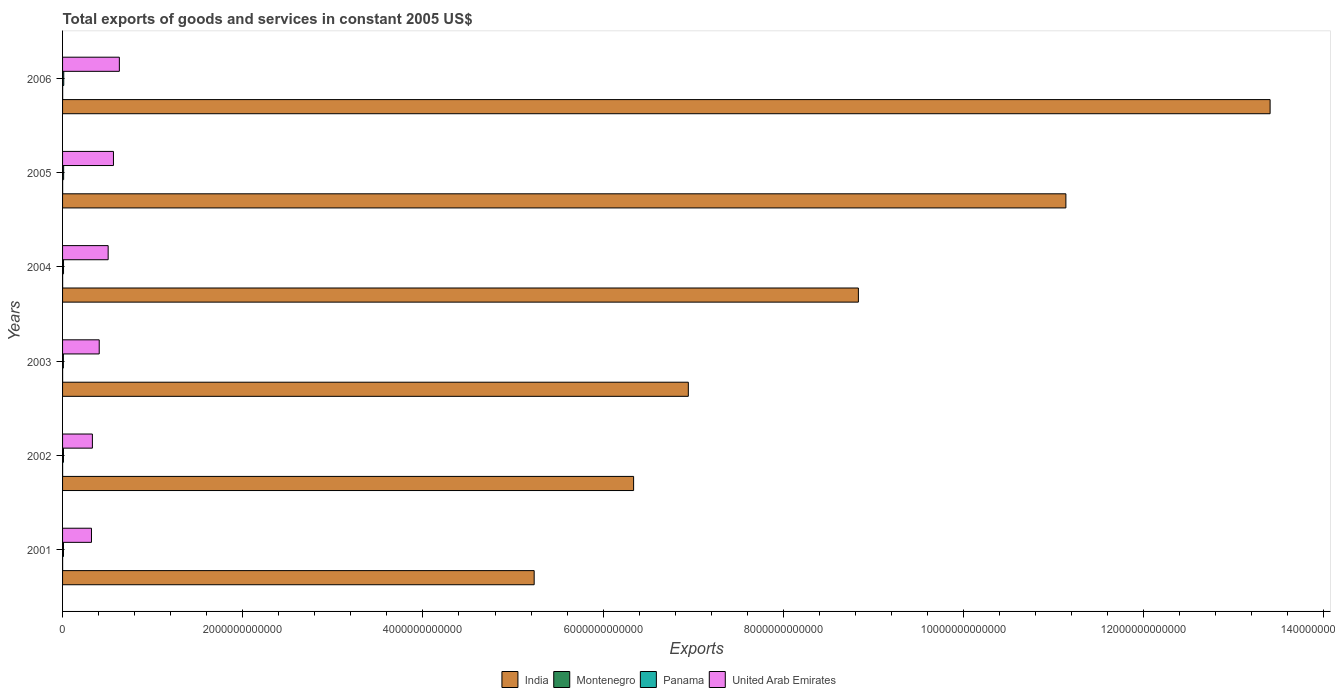How many different coloured bars are there?
Your answer should be compact. 4. How many groups of bars are there?
Your answer should be compact. 6. Are the number of bars per tick equal to the number of legend labels?
Make the answer very short. Yes. Are the number of bars on each tick of the Y-axis equal?
Give a very brief answer. Yes. What is the label of the 6th group of bars from the top?
Your answer should be compact. 2001. What is the total exports of goods and services in United Arab Emirates in 2001?
Offer a terse response. 3.21e+11. Across all years, what is the maximum total exports of goods and services in Panama?
Your response must be concise. 1.32e+1. Across all years, what is the minimum total exports of goods and services in United Arab Emirates?
Keep it short and to the point. 3.21e+11. In which year was the total exports of goods and services in Montenegro minimum?
Give a very brief answer. 2003. What is the total total exports of goods and services in India in the graph?
Provide a short and direct response. 5.19e+13. What is the difference between the total exports of goods and services in India in 2002 and that in 2006?
Your answer should be compact. -7.07e+12. What is the difference between the total exports of goods and services in Panama in 2003 and the total exports of goods and services in United Arab Emirates in 2002?
Make the answer very short. -3.22e+11. What is the average total exports of goods and services in India per year?
Make the answer very short. 8.65e+12. In the year 2005, what is the difference between the total exports of goods and services in India and total exports of goods and services in Montenegro?
Provide a short and direct response. 1.11e+13. In how many years, is the total exports of goods and services in United Arab Emirates greater than 5200000000000 US$?
Your answer should be very brief. 0. What is the ratio of the total exports of goods and services in India in 2004 to that in 2006?
Give a very brief answer. 0.66. Is the total exports of goods and services in Panama in 2001 less than that in 2005?
Make the answer very short. Yes. Is the difference between the total exports of goods and services in India in 2001 and 2005 greater than the difference between the total exports of goods and services in Montenegro in 2001 and 2005?
Offer a very short reply. No. What is the difference between the highest and the second highest total exports of goods and services in Montenegro?
Make the answer very short. 2.01e+08. What is the difference between the highest and the lowest total exports of goods and services in Montenegro?
Offer a terse response. 4.93e+08. Is the sum of the total exports of goods and services in India in 2004 and 2005 greater than the maximum total exports of goods and services in Panama across all years?
Provide a succinct answer. Yes. Is it the case that in every year, the sum of the total exports of goods and services in India and total exports of goods and services in Montenegro is greater than the sum of total exports of goods and services in United Arab Emirates and total exports of goods and services in Panama?
Keep it short and to the point. Yes. What does the 2nd bar from the top in 2002 represents?
Ensure brevity in your answer.  Panama. What does the 2nd bar from the bottom in 2003 represents?
Your response must be concise. Montenegro. Are all the bars in the graph horizontal?
Make the answer very short. Yes. How many years are there in the graph?
Your response must be concise. 6. What is the difference between two consecutive major ticks on the X-axis?
Offer a terse response. 2.00e+12. Are the values on the major ticks of X-axis written in scientific E-notation?
Offer a very short reply. No. Does the graph contain grids?
Your answer should be very brief. No. What is the title of the graph?
Your response must be concise. Total exports of goods and services in constant 2005 US$. What is the label or title of the X-axis?
Offer a very short reply. Exports. What is the Exports of India in 2001?
Ensure brevity in your answer.  5.23e+12. What is the Exports of Montenegro in 2001?
Offer a terse response. 4.67e+08. What is the Exports of Panama in 2001?
Your answer should be very brief. 1.02e+1. What is the Exports of United Arab Emirates in 2001?
Your answer should be compact. 3.21e+11. What is the Exports in India in 2002?
Your response must be concise. 6.34e+12. What is the Exports of Montenegro in 2002?
Keep it short and to the point. 5.32e+08. What is the Exports of Panama in 2002?
Offer a terse response. 9.99e+09. What is the Exports in United Arab Emirates in 2002?
Keep it short and to the point. 3.31e+11. What is the Exports in India in 2003?
Provide a succinct answer. 6.95e+12. What is the Exports in Montenegro in 2003?
Provide a succinct answer. 4.53e+08. What is the Exports of Panama in 2003?
Your answer should be compact. 8.99e+09. What is the Exports of United Arab Emirates in 2003?
Your response must be concise. 4.07e+11. What is the Exports of India in 2004?
Give a very brief answer. 8.83e+12. What is the Exports in Montenegro in 2004?
Offer a terse response. 6.65e+08. What is the Exports of Panama in 2004?
Provide a succinct answer. 1.07e+1. What is the Exports in United Arab Emirates in 2004?
Keep it short and to the point. 5.06e+11. What is the Exports in India in 2005?
Your answer should be very brief. 1.11e+13. What is the Exports in Montenegro in 2005?
Make the answer very short. 7.45e+08. What is the Exports in Panama in 2005?
Offer a very short reply. 1.19e+1. What is the Exports in United Arab Emirates in 2005?
Provide a short and direct response. 5.65e+11. What is the Exports of India in 2006?
Your answer should be very brief. 1.34e+13. What is the Exports of Montenegro in 2006?
Ensure brevity in your answer.  9.46e+08. What is the Exports of Panama in 2006?
Your response must be concise. 1.32e+1. What is the Exports of United Arab Emirates in 2006?
Provide a short and direct response. 6.30e+11. Across all years, what is the maximum Exports in India?
Ensure brevity in your answer.  1.34e+13. Across all years, what is the maximum Exports of Montenegro?
Your answer should be very brief. 9.46e+08. Across all years, what is the maximum Exports in Panama?
Offer a terse response. 1.32e+1. Across all years, what is the maximum Exports in United Arab Emirates?
Give a very brief answer. 6.30e+11. Across all years, what is the minimum Exports in India?
Make the answer very short. 5.23e+12. Across all years, what is the minimum Exports of Montenegro?
Offer a very short reply. 4.53e+08. Across all years, what is the minimum Exports of Panama?
Your response must be concise. 8.99e+09. Across all years, what is the minimum Exports of United Arab Emirates?
Give a very brief answer. 3.21e+11. What is the total Exports in India in the graph?
Offer a terse response. 5.19e+13. What is the total Exports in Montenegro in the graph?
Provide a short and direct response. 3.81e+09. What is the total Exports of Panama in the graph?
Your answer should be compact. 6.49e+1. What is the total Exports of United Arab Emirates in the graph?
Provide a succinct answer. 2.76e+12. What is the difference between the Exports of India in 2001 and that in 2002?
Offer a terse response. -1.10e+12. What is the difference between the Exports of Montenegro in 2001 and that in 2002?
Your answer should be compact. -6.56e+07. What is the difference between the Exports in Panama in 2001 and that in 2002?
Make the answer very short. 2.56e+08. What is the difference between the Exports of United Arab Emirates in 2001 and that in 2002?
Provide a short and direct response. -1.01e+1. What is the difference between the Exports of India in 2001 and that in 2003?
Your response must be concise. -1.71e+12. What is the difference between the Exports of Montenegro in 2001 and that in 2003?
Give a very brief answer. 1.33e+07. What is the difference between the Exports in Panama in 2001 and that in 2003?
Give a very brief answer. 1.26e+09. What is the difference between the Exports in United Arab Emirates in 2001 and that in 2003?
Give a very brief answer. -8.59e+1. What is the difference between the Exports of India in 2001 and that in 2004?
Your response must be concise. -3.60e+12. What is the difference between the Exports in Montenegro in 2001 and that in 2004?
Your answer should be very brief. -1.99e+08. What is the difference between the Exports of Panama in 2001 and that in 2004?
Give a very brief answer. -4.07e+08. What is the difference between the Exports of United Arab Emirates in 2001 and that in 2004?
Offer a terse response. -1.85e+11. What is the difference between the Exports of India in 2001 and that in 2005?
Your response must be concise. -5.90e+12. What is the difference between the Exports in Montenegro in 2001 and that in 2005?
Make the answer very short. -2.79e+08. What is the difference between the Exports of Panama in 2001 and that in 2005?
Keep it short and to the point. -1.61e+09. What is the difference between the Exports of United Arab Emirates in 2001 and that in 2005?
Make the answer very short. -2.44e+11. What is the difference between the Exports of India in 2001 and that in 2006?
Keep it short and to the point. -8.17e+12. What is the difference between the Exports in Montenegro in 2001 and that in 2006?
Ensure brevity in your answer.  -4.79e+08. What is the difference between the Exports of Panama in 2001 and that in 2006?
Make the answer very short. -2.92e+09. What is the difference between the Exports of United Arab Emirates in 2001 and that in 2006?
Your answer should be very brief. -3.10e+11. What is the difference between the Exports in India in 2002 and that in 2003?
Ensure brevity in your answer.  -6.07e+11. What is the difference between the Exports in Montenegro in 2002 and that in 2003?
Ensure brevity in your answer.  7.89e+07. What is the difference between the Exports in Panama in 2002 and that in 2003?
Provide a short and direct response. 1.01e+09. What is the difference between the Exports of United Arab Emirates in 2002 and that in 2003?
Your answer should be very brief. -7.58e+1. What is the difference between the Exports in India in 2002 and that in 2004?
Ensure brevity in your answer.  -2.49e+12. What is the difference between the Exports of Montenegro in 2002 and that in 2004?
Your answer should be very brief. -1.33e+08. What is the difference between the Exports of Panama in 2002 and that in 2004?
Keep it short and to the point. -6.62e+08. What is the difference between the Exports of United Arab Emirates in 2002 and that in 2004?
Your answer should be very brief. -1.75e+11. What is the difference between the Exports of India in 2002 and that in 2005?
Provide a short and direct response. -4.80e+12. What is the difference between the Exports of Montenegro in 2002 and that in 2005?
Your answer should be very brief. -2.13e+08. What is the difference between the Exports in Panama in 2002 and that in 2005?
Ensure brevity in your answer.  -1.87e+09. What is the difference between the Exports of United Arab Emirates in 2002 and that in 2005?
Offer a very short reply. -2.34e+11. What is the difference between the Exports of India in 2002 and that in 2006?
Your response must be concise. -7.07e+12. What is the difference between the Exports of Montenegro in 2002 and that in 2006?
Ensure brevity in your answer.  -4.14e+08. What is the difference between the Exports of Panama in 2002 and that in 2006?
Provide a short and direct response. -3.18e+09. What is the difference between the Exports in United Arab Emirates in 2002 and that in 2006?
Offer a terse response. -2.99e+11. What is the difference between the Exports of India in 2003 and that in 2004?
Your answer should be compact. -1.89e+12. What is the difference between the Exports of Montenegro in 2003 and that in 2004?
Keep it short and to the point. -2.12e+08. What is the difference between the Exports of Panama in 2003 and that in 2004?
Your answer should be very brief. -1.67e+09. What is the difference between the Exports in United Arab Emirates in 2003 and that in 2004?
Offer a terse response. -9.92e+1. What is the difference between the Exports in India in 2003 and that in 2005?
Make the answer very short. -4.19e+12. What is the difference between the Exports of Montenegro in 2003 and that in 2005?
Make the answer very short. -2.92e+08. What is the difference between the Exports in Panama in 2003 and that in 2005?
Provide a succinct answer. -2.87e+09. What is the difference between the Exports of United Arab Emirates in 2003 and that in 2005?
Make the answer very short. -1.58e+11. What is the difference between the Exports of India in 2003 and that in 2006?
Provide a succinct answer. -6.46e+12. What is the difference between the Exports in Montenegro in 2003 and that in 2006?
Provide a short and direct response. -4.93e+08. What is the difference between the Exports in Panama in 2003 and that in 2006?
Your response must be concise. -4.18e+09. What is the difference between the Exports of United Arab Emirates in 2003 and that in 2006?
Ensure brevity in your answer.  -2.24e+11. What is the difference between the Exports in India in 2004 and that in 2005?
Your answer should be very brief. -2.30e+12. What is the difference between the Exports in Montenegro in 2004 and that in 2005?
Your answer should be compact. -8.00e+07. What is the difference between the Exports of Panama in 2004 and that in 2005?
Your answer should be compact. -1.21e+09. What is the difference between the Exports of United Arab Emirates in 2004 and that in 2005?
Your answer should be compact. -5.88e+1. What is the difference between the Exports in India in 2004 and that in 2006?
Offer a terse response. -4.57e+12. What is the difference between the Exports in Montenegro in 2004 and that in 2006?
Ensure brevity in your answer.  -2.81e+08. What is the difference between the Exports of Panama in 2004 and that in 2006?
Offer a terse response. -2.52e+09. What is the difference between the Exports in United Arab Emirates in 2004 and that in 2006?
Your response must be concise. -1.24e+11. What is the difference between the Exports of India in 2005 and that in 2006?
Keep it short and to the point. -2.27e+12. What is the difference between the Exports of Montenegro in 2005 and that in 2006?
Provide a succinct answer. -2.01e+08. What is the difference between the Exports of Panama in 2005 and that in 2006?
Make the answer very short. -1.31e+09. What is the difference between the Exports in United Arab Emirates in 2005 and that in 2006?
Make the answer very short. -6.56e+1. What is the difference between the Exports of India in 2001 and the Exports of Montenegro in 2002?
Provide a short and direct response. 5.23e+12. What is the difference between the Exports in India in 2001 and the Exports in Panama in 2002?
Make the answer very short. 5.22e+12. What is the difference between the Exports of India in 2001 and the Exports of United Arab Emirates in 2002?
Provide a short and direct response. 4.90e+12. What is the difference between the Exports in Montenegro in 2001 and the Exports in Panama in 2002?
Your response must be concise. -9.53e+09. What is the difference between the Exports in Montenegro in 2001 and the Exports in United Arab Emirates in 2002?
Your response must be concise. -3.31e+11. What is the difference between the Exports in Panama in 2001 and the Exports in United Arab Emirates in 2002?
Offer a terse response. -3.21e+11. What is the difference between the Exports in India in 2001 and the Exports in Montenegro in 2003?
Your answer should be very brief. 5.23e+12. What is the difference between the Exports in India in 2001 and the Exports in Panama in 2003?
Keep it short and to the point. 5.23e+12. What is the difference between the Exports of India in 2001 and the Exports of United Arab Emirates in 2003?
Your answer should be very brief. 4.83e+12. What is the difference between the Exports of Montenegro in 2001 and the Exports of Panama in 2003?
Keep it short and to the point. -8.52e+09. What is the difference between the Exports in Montenegro in 2001 and the Exports in United Arab Emirates in 2003?
Provide a succinct answer. -4.06e+11. What is the difference between the Exports in Panama in 2001 and the Exports in United Arab Emirates in 2003?
Provide a short and direct response. -3.97e+11. What is the difference between the Exports in India in 2001 and the Exports in Montenegro in 2004?
Offer a terse response. 5.23e+12. What is the difference between the Exports of India in 2001 and the Exports of Panama in 2004?
Your response must be concise. 5.22e+12. What is the difference between the Exports of India in 2001 and the Exports of United Arab Emirates in 2004?
Keep it short and to the point. 4.73e+12. What is the difference between the Exports of Montenegro in 2001 and the Exports of Panama in 2004?
Offer a very short reply. -1.02e+1. What is the difference between the Exports in Montenegro in 2001 and the Exports in United Arab Emirates in 2004?
Provide a succinct answer. -5.06e+11. What is the difference between the Exports of Panama in 2001 and the Exports of United Arab Emirates in 2004?
Give a very brief answer. -4.96e+11. What is the difference between the Exports of India in 2001 and the Exports of Montenegro in 2005?
Make the answer very short. 5.23e+12. What is the difference between the Exports of India in 2001 and the Exports of Panama in 2005?
Keep it short and to the point. 5.22e+12. What is the difference between the Exports of India in 2001 and the Exports of United Arab Emirates in 2005?
Your response must be concise. 4.67e+12. What is the difference between the Exports of Montenegro in 2001 and the Exports of Panama in 2005?
Keep it short and to the point. -1.14e+1. What is the difference between the Exports in Montenegro in 2001 and the Exports in United Arab Emirates in 2005?
Ensure brevity in your answer.  -5.64e+11. What is the difference between the Exports in Panama in 2001 and the Exports in United Arab Emirates in 2005?
Your response must be concise. -5.55e+11. What is the difference between the Exports of India in 2001 and the Exports of Montenegro in 2006?
Offer a terse response. 5.23e+12. What is the difference between the Exports of India in 2001 and the Exports of Panama in 2006?
Provide a succinct answer. 5.22e+12. What is the difference between the Exports in India in 2001 and the Exports in United Arab Emirates in 2006?
Your answer should be very brief. 4.60e+12. What is the difference between the Exports of Montenegro in 2001 and the Exports of Panama in 2006?
Your response must be concise. -1.27e+1. What is the difference between the Exports in Montenegro in 2001 and the Exports in United Arab Emirates in 2006?
Your answer should be very brief. -6.30e+11. What is the difference between the Exports in Panama in 2001 and the Exports in United Arab Emirates in 2006?
Offer a terse response. -6.20e+11. What is the difference between the Exports of India in 2002 and the Exports of Montenegro in 2003?
Provide a short and direct response. 6.34e+12. What is the difference between the Exports in India in 2002 and the Exports in Panama in 2003?
Give a very brief answer. 6.33e+12. What is the difference between the Exports of India in 2002 and the Exports of United Arab Emirates in 2003?
Ensure brevity in your answer.  5.93e+12. What is the difference between the Exports of Montenegro in 2002 and the Exports of Panama in 2003?
Make the answer very short. -8.46e+09. What is the difference between the Exports of Montenegro in 2002 and the Exports of United Arab Emirates in 2003?
Keep it short and to the point. -4.06e+11. What is the difference between the Exports in Panama in 2002 and the Exports in United Arab Emirates in 2003?
Provide a short and direct response. -3.97e+11. What is the difference between the Exports of India in 2002 and the Exports of Montenegro in 2004?
Provide a succinct answer. 6.34e+12. What is the difference between the Exports in India in 2002 and the Exports in Panama in 2004?
Give a very brief answer. 6.33e+12. What is the difference between the Exports of India in 2002 and the Exports of United Arab Emirates in 2004?
Offer a terse response. 5.83e+12. What is the difference between the Exports of Montenegro in 2002 and the Exports of Panama in 2004?
Your answer should be compact. -1.01e+1. What is the difference between the Exports in Montenegro in 2002 and the Exports in United Arab Emirates in 2004?
Provide a succinct answer. -5.05e+11. What is the difference between the Exports of Panama in 2002 and the Exports of United Arab Emirates in 2004?
Your answer should be compact. -4.96e+11. What is the difference between the Exports of India in 2002 and the Exports of Montenegro in 2005?
Your answer should be very brief. 6.34e+12. What is the difference between the Exports of India in 2002 and the Exports of Panama in 2005?
Ensure brevity in your answer.  6.33e+12. What is the difference between the Exports of India in 2002 and the Exports of United Arab Emirates in 2005?
Provide a succinct answer. 5.77e+12. What is the difference between the Exports in Montenegro in 2002 and the Exports in Panama in 2005?
Ensure brevity in your answer.  -1.13e+1. What is the difference between the Exports of Montenegro in 2002 and the Exports of United Arab Emirates in 2005?
Make the answer very short. -5.64e+11. What is the difference between the Exports of Panama in 2002 and the Exports of United Arab Emirates in 2005?
Keep it short and to the point. -5.55e+11. What is the difference between the Exports of India in 2002 and the Exports of Montenegro in 2006?
Provide a succinct answer. 6.34e+12. What is the difference between the Exports of India in 2002 and the Exports of Panama in 2006?
Your answer should be very brief. 6.33e+12. What is the difference between the Exports in India in 2002 and the Exports in United Arab Emirates in 2006?
Your answer should be very brief. 5.71e+12. What is the difference between the Exports in Montenegro in 2002 and the Exports in Panama in 2006?
Your answer should be compact. -1.26e+1. What is the difference between the Exports in Montenegro in 2002 and the Exports in United Arab Emirates in 2006?
Provide a succinct answer. -6.30e+11. What is the difference between the Exports of Panama in 2002 and the Exports of United Arab Emirates in 2006?
Keep it short and to the point. -6.20e+11. What is the difference between the Exports in India in 2003 and the Exports in Montenegro in 2004?
Give a very brief answer. 6.95e+12. What is the difference between the Exports of India in 2003 and the Exports of Panama in 2004?
Keep it short and to the point. 6.94e+12. What is the difference between the Exports in India in 2003 and the Exports in United Arab Emirates in 2004?
Ensure brevity in your answer.  6.44e+12. What is the difference between the Exports in Montenegro in 2003 and the Exports in Panama in 2004?
Provide a succinct answer. -1.02e+1. What is the difference between the Exports in Montenegro in 2003 and the Exports in United Arab Emirates in 2004?
Keep it short and to the point. -5.06e+11. What is the difference between the Exports of Panama in 2003 and the Exports of United Arab Emirates in 2004?
Your response must be concise. -4.97e+11. What is the difference between the Exports in India in 2003 and the Exports in Montenegro in 2005?
Your answer should be very brief. 6.95e+12. What is the difference between the Exports of India in 2003 and the Exports of Panama in 2005?
Your response must be concise. 6.93e+12. What is the difference between the Exports of India in 2003 and the Exports of United Arab Emirates in 2005?
Make the answer very short. 6.38e+12. What is the difference between the Exports of Montenegro in 2003 and the Exports of Panama in 2005?
Your answer should be compact. -1.14e+1. What is the difference between the Exports in Montenegro in 2003 and the Exports in United Arab Emirates in 2005?
Offer a very short reply. -5.64e+11. What is the difference between the Exports of Panama in 2003 and the Exports of United Arab Emirates in 2005?
Your response must be concise. -5.56e+11. What is the difference between the Exports in India in 2003 and the Exports in Montenegro in 2006?
Provide a succinct answer. 6.94e+12. What is the difference between the Exports of India in 2003 and the Exports of Panama in 2006?
Give a very brief answer. 6.93e+12. What is the difference between the Exports in India in 2003 and the Exports in United Arab Emirates in 2006?
Give a very brief answer. 6.32e+12. What is the difference between the Exports of Montenegro in 2003 and the Exports of Panama in 2006?
Your answer should be compact. -1.27e+1. What is the difference between the Exports of Montenegro in 2003 and the Exports of United Arab Emirates in 2006?
Give a very brief answer. -6.30e+11. What is the difference between the Exports in Panama in 2003 and the Exports in United Arab Emirates in 2006?
Your answer should be very brief. -6.21e+11. What is the difference between the Exports in India in 2004 and the Exports in Montenegro in 2005?
Ensure brevity in your answer.  8.83e+12. What is the difference between the Exports of India in 2004 and the Exports of Panama in 2005?
Your answer should be compact. 8.82e+12. What is the difference between the Exports in India in 2004 and the Exports in United Arab Emirates in 2005?
Provide a short and direct response. 8.27e+12. What is the difference between the Exports of Montenegro in 2004 and the Exports of Panama in 2005?
Your response must be concise. -1.12e+1. What is the difference between the Exports of Montenegro in 2004 and the Exports of United Arab Emirates in 2005?
Provide a short and direct response. -5.64e+11. What is the difference between the Exports in Panama in 2004 and the Exports in United Arab Emirates in 2005?
Offer a terse response. -5.54e+11. What is the difference between the Exports in India in 2004 and the Exports in Montenegro in 2006?
Ensure brevity in your answer.  8.83e+12. What is the difference between the Exports of India in 2004 and the Exports of Panama in 2006?
Make the answer very short. 8.82e+12. What is the difference between the Exports of India in 2004 and the Exports of United Arab Emirates in 2006?
Provide a succinct answer. 8.20e+12. What is the difference between the Exports of Montenegro in 2004 and the Exports of Panama in 2006?
Give a very brief answer. -1.25e+1. What is the difference between the Exports in Montenegro in 2004 and the Exports in United Arab Emirates in 2006?
Your answer should be very brief. -6.30e+11. What is the difference between the Exports in Panama in 2004 and the Exports in United Arab Emirates in 2006?
Keep it short and to the point. -6.20e+11. What is the difference between the Exports of India in 2005 and the Exports of Montenegro in 2006?
Keep it short and to the point. 1.11e+13. What is the difference between the Exports in India in 2005 and the Exports in Panama in 2006?
Your answer should be very brief. 1.11e+13. What is the difference between the Exports in India in 2005 and the Exports in United Arab Emirates in 2006?
Your answer should be very brief. 1.05e+13. What is the difference between the Exports of Montenegro in 2005 and the Exports of Panama in 2006?
Keep it short and to the point. -1.24e+1. What is the difference between the Exports of Montenegro in 2005 and the Exports of United Arab Emirates in 2006?
Your answer should be compact. -6.30e+11. What is the difference between the Exports in Panama in 2005 and the Exports in United Arab Emirates in 2006?
Offer a very short reply. -6.19e+11. What is the average Exports of India per year?
Your response must be concise. 8.65e+12. What is the average Exports of Montenegro per year?
Ensure brevity in your answer.  6.35e+08. What is the average Exports in Panama per year?
Make the answer very short. 1.08e+1. What is the average Exports of United Arab Emirates per year?
Offer a terse response. 4.60e+11. In the year 2001, what is the difference between the Exports in India and Exports in Montenegro?
Provide a short and direct response. 5.23e+12. In the year 2001, what is the difference between the Exports of India and Exports of Panama?
Keep it short and to the point. 5.22e+12. In the year 2001, what is the difference between the Exports of India and Exports of United Arab Emirates?
Give a very brief answer. 4.91e+12. In the year 2001, what is the difference between the Exports of Montenegro and Exports of Panama?
Your response must be concise. -9.78e+09. In the year 2001, what is the difference between the Exports of Montenegro and Exports of United Arab Emirates?
Make the answer very short. -3.20e+11. In the year 2001, what is the difference between the Exports in Panama and Exports in United Arab Emirates?
Keep it short and to the point. -3.11e+11. In the year 2002, what is the difference between the Exports of India and Exports of Montenegro?
Ensure brevity in your answer.  6.34e+12. In the year 2002, what is the difference between the Exports in India and Exports in Panama?
Ensure brevity in your answer.  6.33e+12. In the year 2002, what is the difference between the Exports of India and Exports of United Arab Emirates?
Your response must be concise. 6.01e+12. In the year 2002, what is the difference between the Exports of Montenegro and Exports of Panama?
Ensure brevity in your answer.  -9.46e+09. In the year 2002, what is the difference between the Exports in Montenegro and Exports in United Arab Emirates?
Your answer should be compact. -3.30e+11. In the year 2002, what is the difference between the Exports of Panama and Exports of United Arab Emirates?
Give a very brief answer. -3.21e+11. In the year 2003, what is the difference between the Exports of India and Exports of Montenegro?
Provide a succinct answer. 6.95e+12. In the year 2003, what is the difference between the Exports of India and Exports of Panama?
Offer a terse response. 6.94e+12. In the year 2003, what is the difference between the Exports in India and Exports in United Arab Emirates?
Ensure brevity in your answer.  6.54e+12. In the year 2003, what is the difference between the Exports in Montenegro and Exports in Panama?
Your response must be concise. -8.54e+09. In the year 2003, what is the difference between the Exports in Montenegro and Exports in United Arab Emirates?
Your response must be concise. -4.06e+11. In the year 2003, what is the difference between the Exports in Panama and Exports in United Arab Emirates?
Give a very brief answer. -3.98e+11. In the year 2004, what is the difference between the Exports in India and Exports in Montenegro?
Your response must be concise. 8.83e+12. In the year 2004, what is the difference between the Exports in India and Exports in Panama?
Offer a terse response. 8.82e+12. In the year 2004, what is the difference between the Exports in India and Exports in United Arab Emirates?
Your answer should be very brief. 8.33e+12. In the year 2004, what is the difference between the Exports in Montenegro and Exports in Panama?
Provide a succinct answer. -9.99e+09. In the year 2004, what is the difference between the Exports in Montenegro and Exports in United Arab Emirates?
Ensure brevity in your answer.  -5.05e+11. In the year 2004, what is the difference between the Exports of Panama and Exports of United Arab Emirates?
Your response must be concise. -4.95e+11. In the year 2005, what is the difference between the Exports of India and Exports of Montenegro?
Your answer should be very brief. 1.11e+13. In the year 2005, what is the difference between the Exports of India and Exports of Panama?
Offer a terse response. 1.11e+13. In the year 2005, what is the difference between the Exports in India and Exports in United Arab Emirates?
Keep it short and to the point. 1.06e+13. In the year 2005, what is the difference between the Exports of Montenegro and Exports of Panama?
Provide a succinct answer. -1.11e+1. In the year 2005, what is the difference between the Exports of Montenegro and Exports of United Arab Emirates?
Offer a very short reply. -5.64e+11. In the year 2005, what is the difference between the Exports of Panama and Exports of United Arab Emirates?
Give a very brief answer. -5.53e+11. In the year 2006, what is the difference between the Exports in India and Exports in Montenegro?
Ensure brevity in your answer.  1.34e+13. In the year 2006, what is the difference between the Exports in India and Exports in Panama?
Offer a terse response. 1.34e+13. In the year 2006, what is the difference between the Exports in India and Exports in United Arab Emirates?
Offer a very short reply. 1.28e+13. In the year 2006, what is the difference between the Exports of Montenegro and Exports of Panama?
Give a very brief answer. -1.22e+1. In the year 2006, what is the difference between the Exports of Montenegro and Exports of United Arab Emirates?
Your answer should be very brief. -6.29e+11. In the year 2006, what is the difference between the Exports of Panama and Exports of United Arab Emirates?
Provide a short and direct response. -6.17e+11. What is the ratio of the Exports in India in 2001 to that in 2002?
Offer a very short reply. 0.83. What is the ratio of the Exports in Montenegro in 2001 to that in 2002?
Provide a short and direct response. 0.88. What is the ratio of the Exports of Panama in 2001 to that in 2002?
Make the answer very short. 1.03. What is the ratio of the Exports of United Arab Emirates in 2001 to that in 2002?
Your answer should be compact. 0.97. What is the ratio of the Exports in India in 2001 to that in 2003?
Your response must be concise. 0.75. What is the ratio of the Exports of Montenegro in 2001 to that in 2003?
Give a very brief answer. 1.03. What is the ratio of the Exports of Panama in 2001 to that in 2003?
Keep it short and to the point. 1.14. What is the ratio of the Exports in United Arab Emirates in 2001 to that in 2003?
Give a very brief answer. 0.79. What is the ratio of the Exports of India in 2001 to that in 2004?
Ensure brevity in your answer.  0.59. What is the ratio of the Exports of Montenegro in 2001 to that in 2004?
Ensure brevity in your answer.  0.7. What is the ratio of the Exports in Panama in 2001 to that in 2004?
Make the answer very short. 0.96. What is the ratio of the Exports in United Arab Emirates in 2001 to that in 2004?
Make the answer very short. 0.63. What is the ratio of the Exports of India in 2001 to that in 2005?
Offer a very short reply. 0.47. What is the ratio of the Exports of Montenegro in 2001 to that in 2005?
Make the answer very short. 0.63. What is the ratio of the Exports in Panama in 2001 to that in 2005?
Make the answer very short. 0.86. What is the ratio of the Exports in United Arab Emirates in 2001 to that in 2005?
Your answer should be compact. 0.57. What is the ratio of the Exports in India in 2001 to that in 2006?
Offer a terse response. 0.39. What is the ratio of the Exports in Montenegro in 2001 to that in 2006?
Make the answer very short. 0.49. What is the ratio of the Exports of Panama in 2001 to that in 2006?
Your answer should be very brief. 0.78. What is the ratio of the Exports in United Arab Emirates in 2001 to that in 2006?
Your answer should be compact. 0.51. What is the ratio of the Exports of India in 2002 to that in 2003?
Your answer should be compact. 0.91. What is the ratio of the Exports of Montenegro in 2002 to that in 2003?
Offer a terse response. 1.17. What is the ratio of the Exports of Panama in 2002 to that in 2003?
Provide a succinct answer. 1.11. What is the ratio of the Exports of United Arab Emirates in 2002 to that in 2003?
Offer a very short reply. 0.81. What is the ratio of the Exports in India in 2002 to that in 2004?
Offer a terse response. 0.72. What is the ratio of the Exports of Montenegro in 2002 to that in 2004?
Keep it short and to the point. 0.8. What is the ratio of the Exports of Panama in 2002 to that in 2004?
Make the answer very short. 0.94. What is the ratio of the Exports in United Arab Emirates in 2002 to that in 2004?
Provide a succinct answer. 0.65. What is the ratio of the Exports in India in 2002 to that in 2005?
Ensure brevity in your answer.  0.57. What is the ratio of the Exports of Montenegro in 2002 to that in 2005?
Ensure brevity in your answer.  0.71. What is the ratio of the Exports in Panama in 2002 to that in 2005?
Provide a succinct answer. 0.84. What is the ratio of the Exports of United Arab Emirates in 2002 to that in 2005?
Your answer should be compact. 0.59. What is the ratio of the Exports of India in 2002 to that in 2006?
Provide a short and direct response. 0.47. What is the ratio of the Exports of Montenegro in 2002 to that in 2006?
Keep it short and to the point. 0.56. What is the ratio of the Exports of Panama in 2002 to that in 2006?
Make the answer very short. 0.76. What is the ratio of the Exports of United Arab Emirates in 2002 to that in 2006?
Your answer should be compact. 0.53. What is the ratio of the Exports in India in 2003 to that in 2004?
Your answer should be very brief. 0.79. What is the ratio of the Exports in Montenegro in 2003 to that in 2004?
Give a very brief answer. 0.68. What is the ratio of the Exports in Panama in 2003 to that in 2004?
Provide a succinct answer. 0.84. What is the ratio of the Exports of United Arab Emirates in 2003 to that in 2004?
Your answer should be very brief. 0.8. What is the ratio of the Exports of India in 2003 to that in 2005?
Provide a short and direct response. 0.62. What is the ratio of the Exports in Montenegro in 2003 to that in 2005?
Ensure brevity in your answer.  0.61. What is the ratio of the Exports in Panama in 2003 to that in 2005?
Your answer should be compact. 0.76. What is the ratio of the Exports of United Arab Emirates in 2003 to that in 2005?
Ensure brevity in your answer.  0.72. What is the ratio of the Exports of India in 2003 to that in 2006?
Make the answer very short. 0.52. What is the ratio of the Exports in Montenegro in 2003 to that in 2006?
Make the answer very short. 0.48. What is the ratio of the Exports of Panama in 2003 to that in 2006?
Provide a succinct answer. 0.68. What is the ratio of the Exports in United Arab Emirates in 2003 to that in 2006?
Ensure brevity in your answer.  0.65. What is the ratio of the Exports in India in 2004 to that in 2005?
Provide a short and direct response. 0.79. What is the ratio of the Exports in Montenegro in 2004 to that in 2005?
Your answer should be very brief. 0.89. What is the ratio of the Exports of Panama in 2004 to that in 2005?
Offer a terse response. 0.9. What is the ratio of the Exports of United Arab Emirates in 2004 to that in 2005?
Keep it short and to the point. 0.9. What is the ratio of the Exports of India in 2004 to that in 2006?
Offer a very short reply. 0.66. What is the ratio of the Exports in Montenegro in 2004 to that in 2006?
Give a very brief answer. 0.7. What is the ratio of the Exports of Panama in 2004 to that in 2006?
Your response must be concise. 0.81. What is the ratio of the Exports in United Arab Emirates in 2004 to that in 2006?
Your answer should be very brief. 0.8. What is the ratio of the Exports of India in 2005 to that in 2006?
Provide a succinct answer. 0.83. What is the ratio of the Exports of Montenegro in 2005 to that in 2006?
Give a very brief answer. 0.79. What is the ratio of the Exports of Panama in 2005 to that in 2006?
Your answer should be very brief. 0.9. What is the ratio of the Exports in United Arab Emirates in 2005 to that in 2006?
Ensure brevity in your answer.  0.9. What is the difference between the highest and the second highest Exports in India?
Make the answer very short. 2.27e+12. What is the difference between the highest and the second highest Exports of Montenegro?
Your answer should be very brief. 2.01e+08. What is the difference between the highest and the second highest Exports in Panama?
Ensure brevity in your answer.  1.31e+09. What is the difference between the highest and the second highest Exports of United Arab Emirates?
Provide a short and direct response. 6.56e+1. What is the difference between the highest and the lowest Exports in India?
Provide a succinct answer. 8.17e+12. What is the difference between the highest and the lowest Exports in Montenegro?
Offer a very short reply. 4.93e+08. What is the difference between the highest and the lowest Exports of Panama?
Make the answer very short. 4.18e+09. What is the difference between the highest and the lowest Exports in United Arab Emirates?
Your answer should be compact. 3.10e+11. 